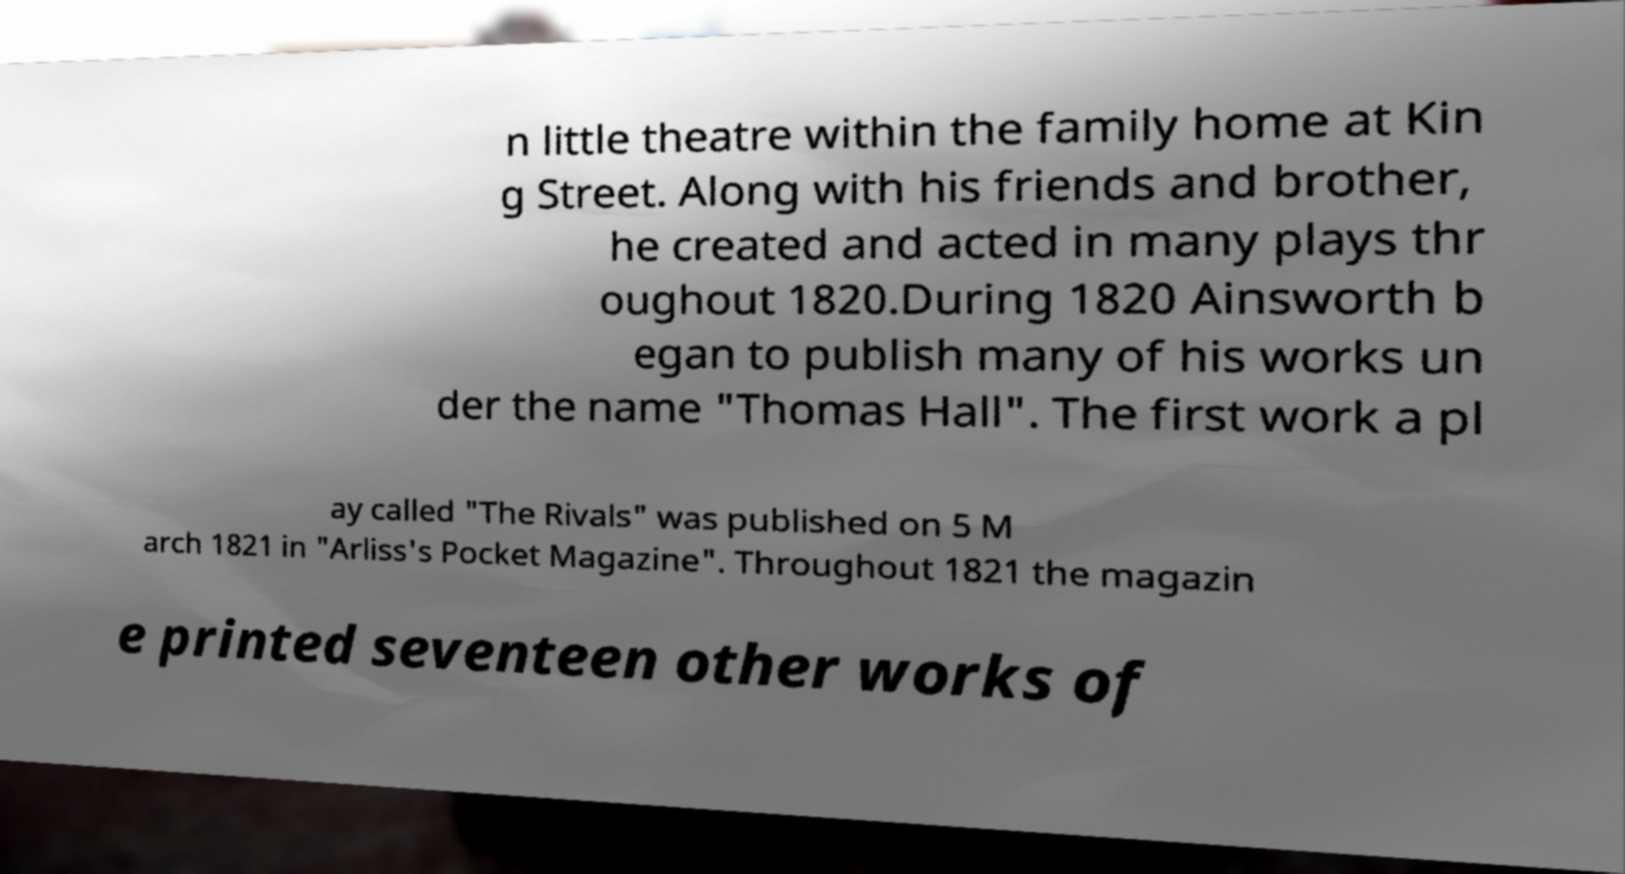Could you assist in decoding the text presented in this image and type it out clearly? n little theatre within the family home at Kin g Street. Along with his friends and brother, he created and acted in many plays thr oughout 1820.During 1820 Ainsworth b egan to publish many of his works un der the name "Thomas Hall". The first work a pl ay called "The Rivals" was published on 5 M arch 1821 in "Arliss's Pocket Magazine". Throughout 1821 the magazin e printed seventeen other works of 